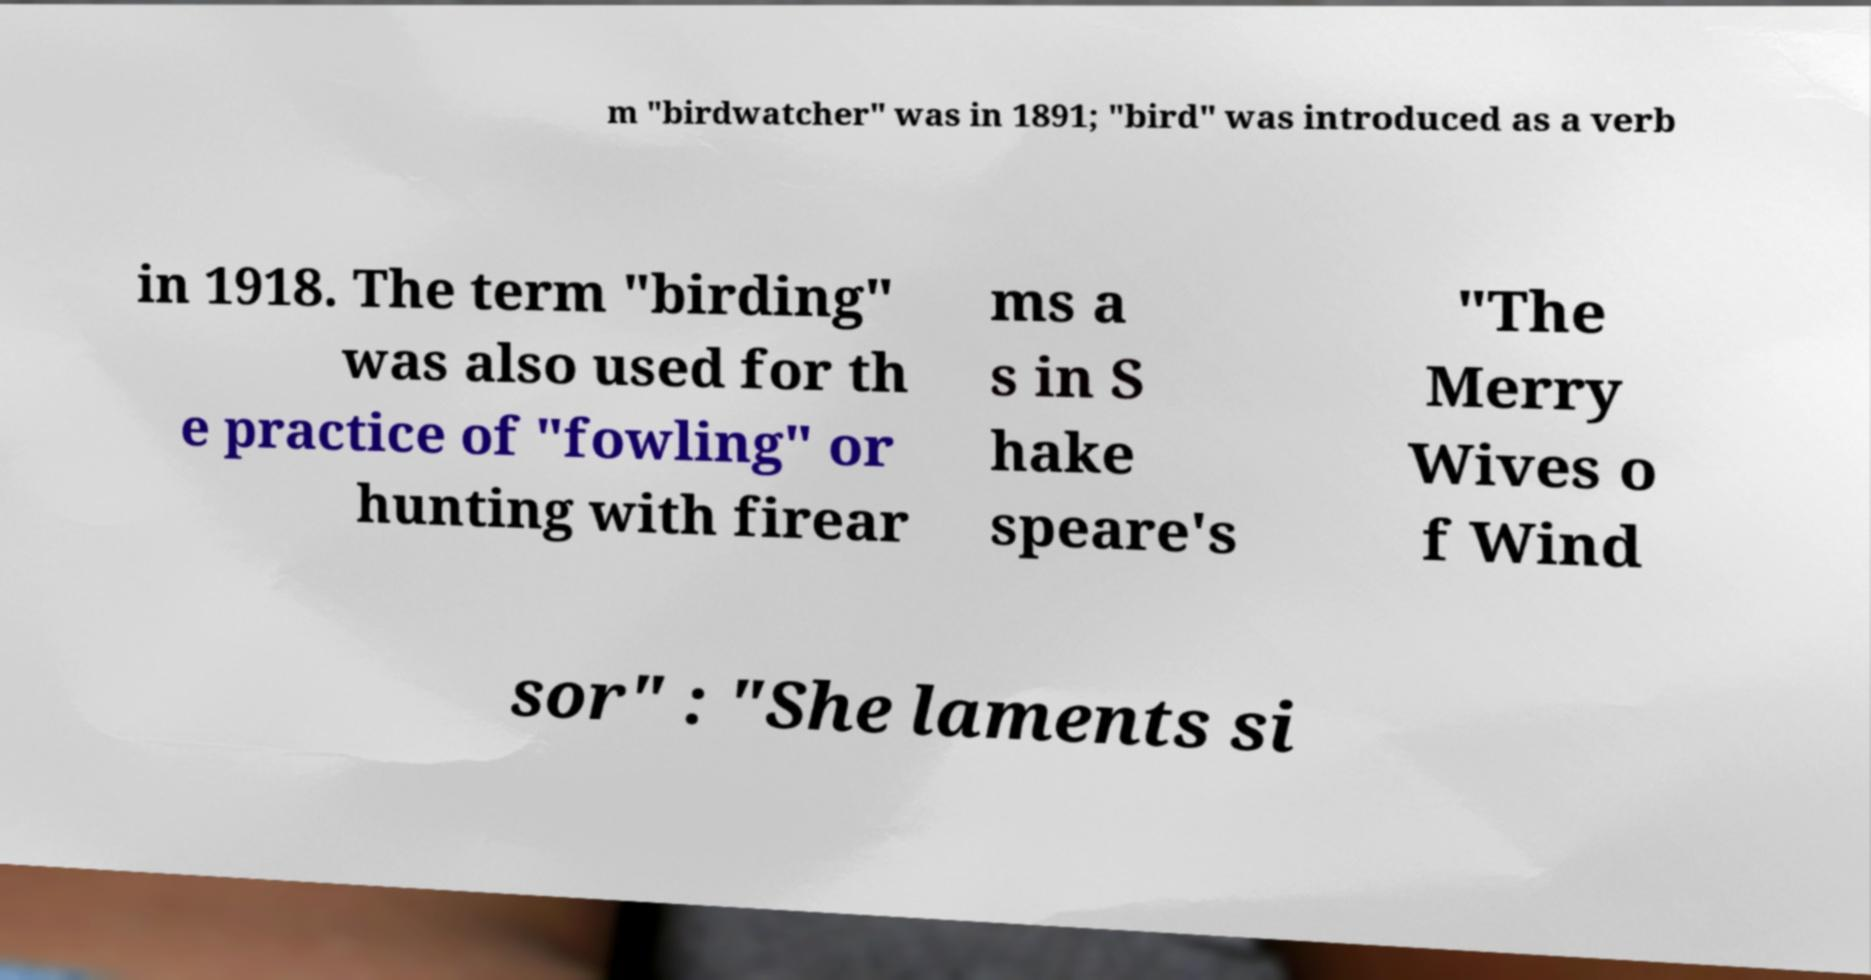There's text embedded in this image that I need extracted. Can you transcribe it verbatim? m "birdwatcher" was in 1891; "bird" was introduced as a verb in 1918. The term "birding" was also used for th e practice of "fowling" or hunting with firear ms a s in S hake speare's "The Merry Wives o f Wind sor" : "She laments si 